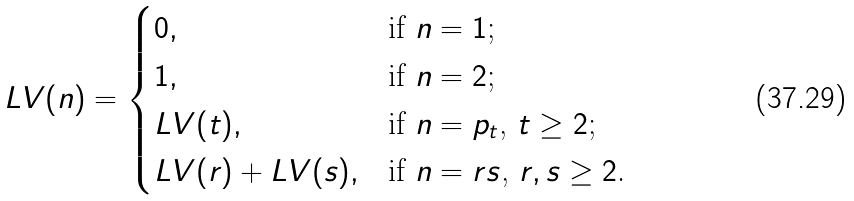<formula> <loc_0><loc_0><loc_500><loc_500>L V ( n ) = \begin{cases} 0 , & \text {if $n=1$;} \\ 1 , & \text {if $n=2$;} \\ L V ( t ) , & \text {if $n=p_{t}$, $t\geq 2$;} \\ L V ( r ) + L V ( s ) , & \text {if $n=rs$, $r,s \geq 2$.} \end{cases}</formula> 